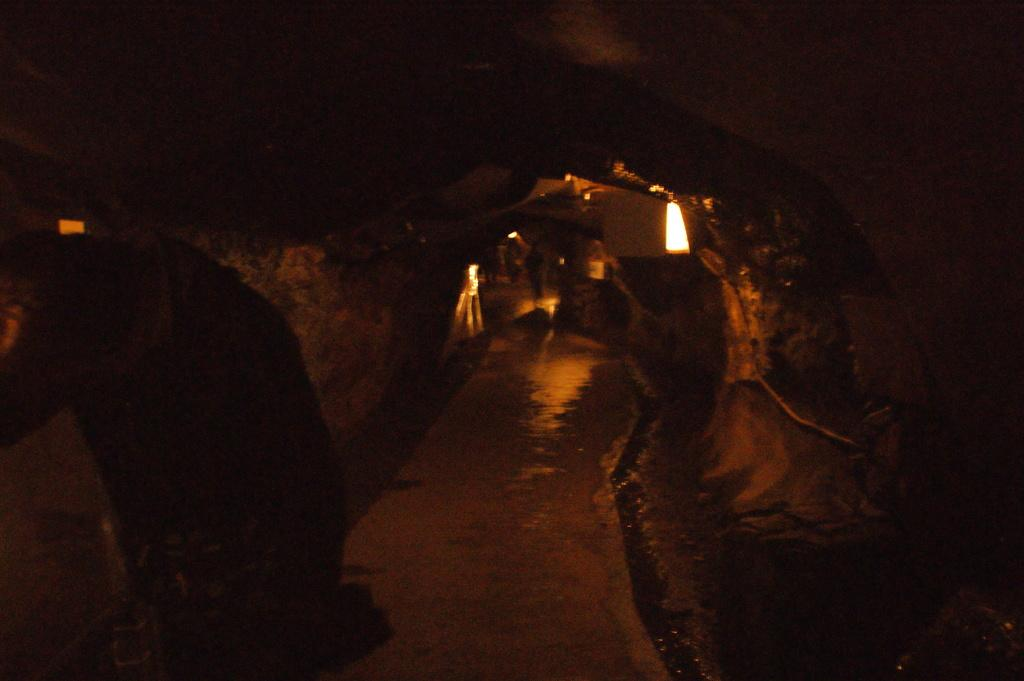What type of location is depicted in the image? The image shows the inside view of a cave. What can be seen on the floor of the cave? The ground is visible in the image. Are there any objects present in the cave? Yes, there are objects present in the image. What is used to illuminate the cave in the image? Lights are visible in the image. What is the name of the daughter who is exploring the cave in the image? There is no daughter present in the image, and the image does not depict anyone exploring the cave. 